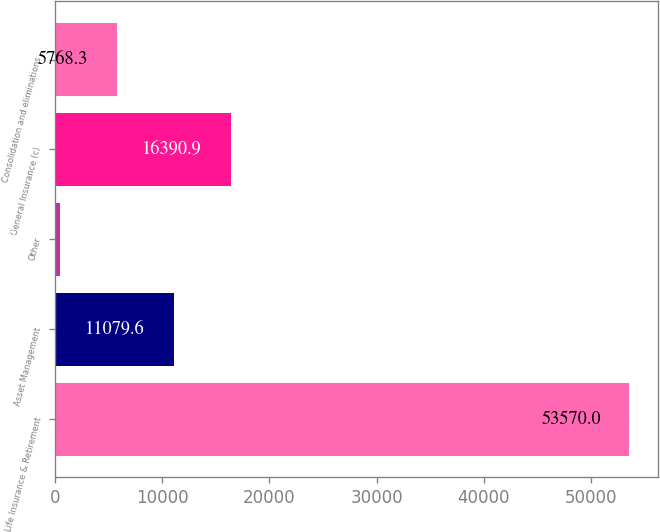Convert chart to OTSL. <chart><loc_0><loc_0><loc_500><loc_500><bar_chart><fcel>Life Insurance & Retirement<fcel>Asset Management<fcel>Other<fcel>General Insurance (c)<fcel>Consolidation and eliminations<nl><fcel>53570<fcel>11079.6<fcel>457<fcel>16390.9<fcel>5768.3<nl></chart> 